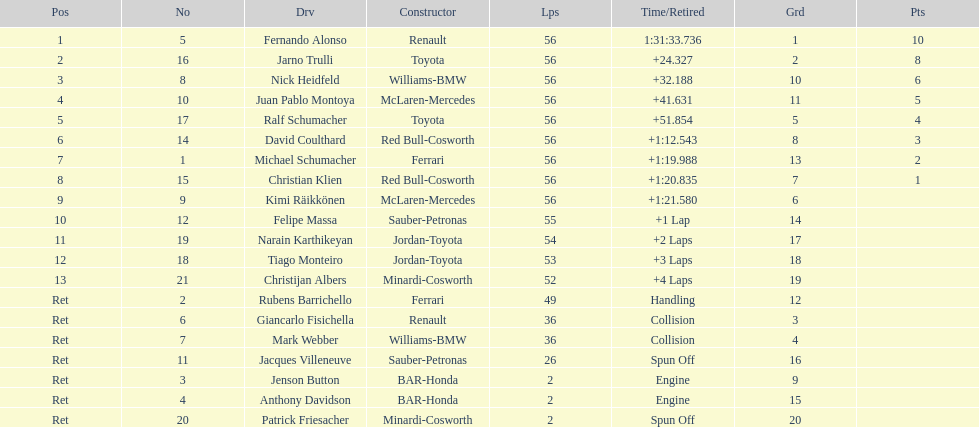In what amount of time did heidfeld complete? 1:31:65.924. 